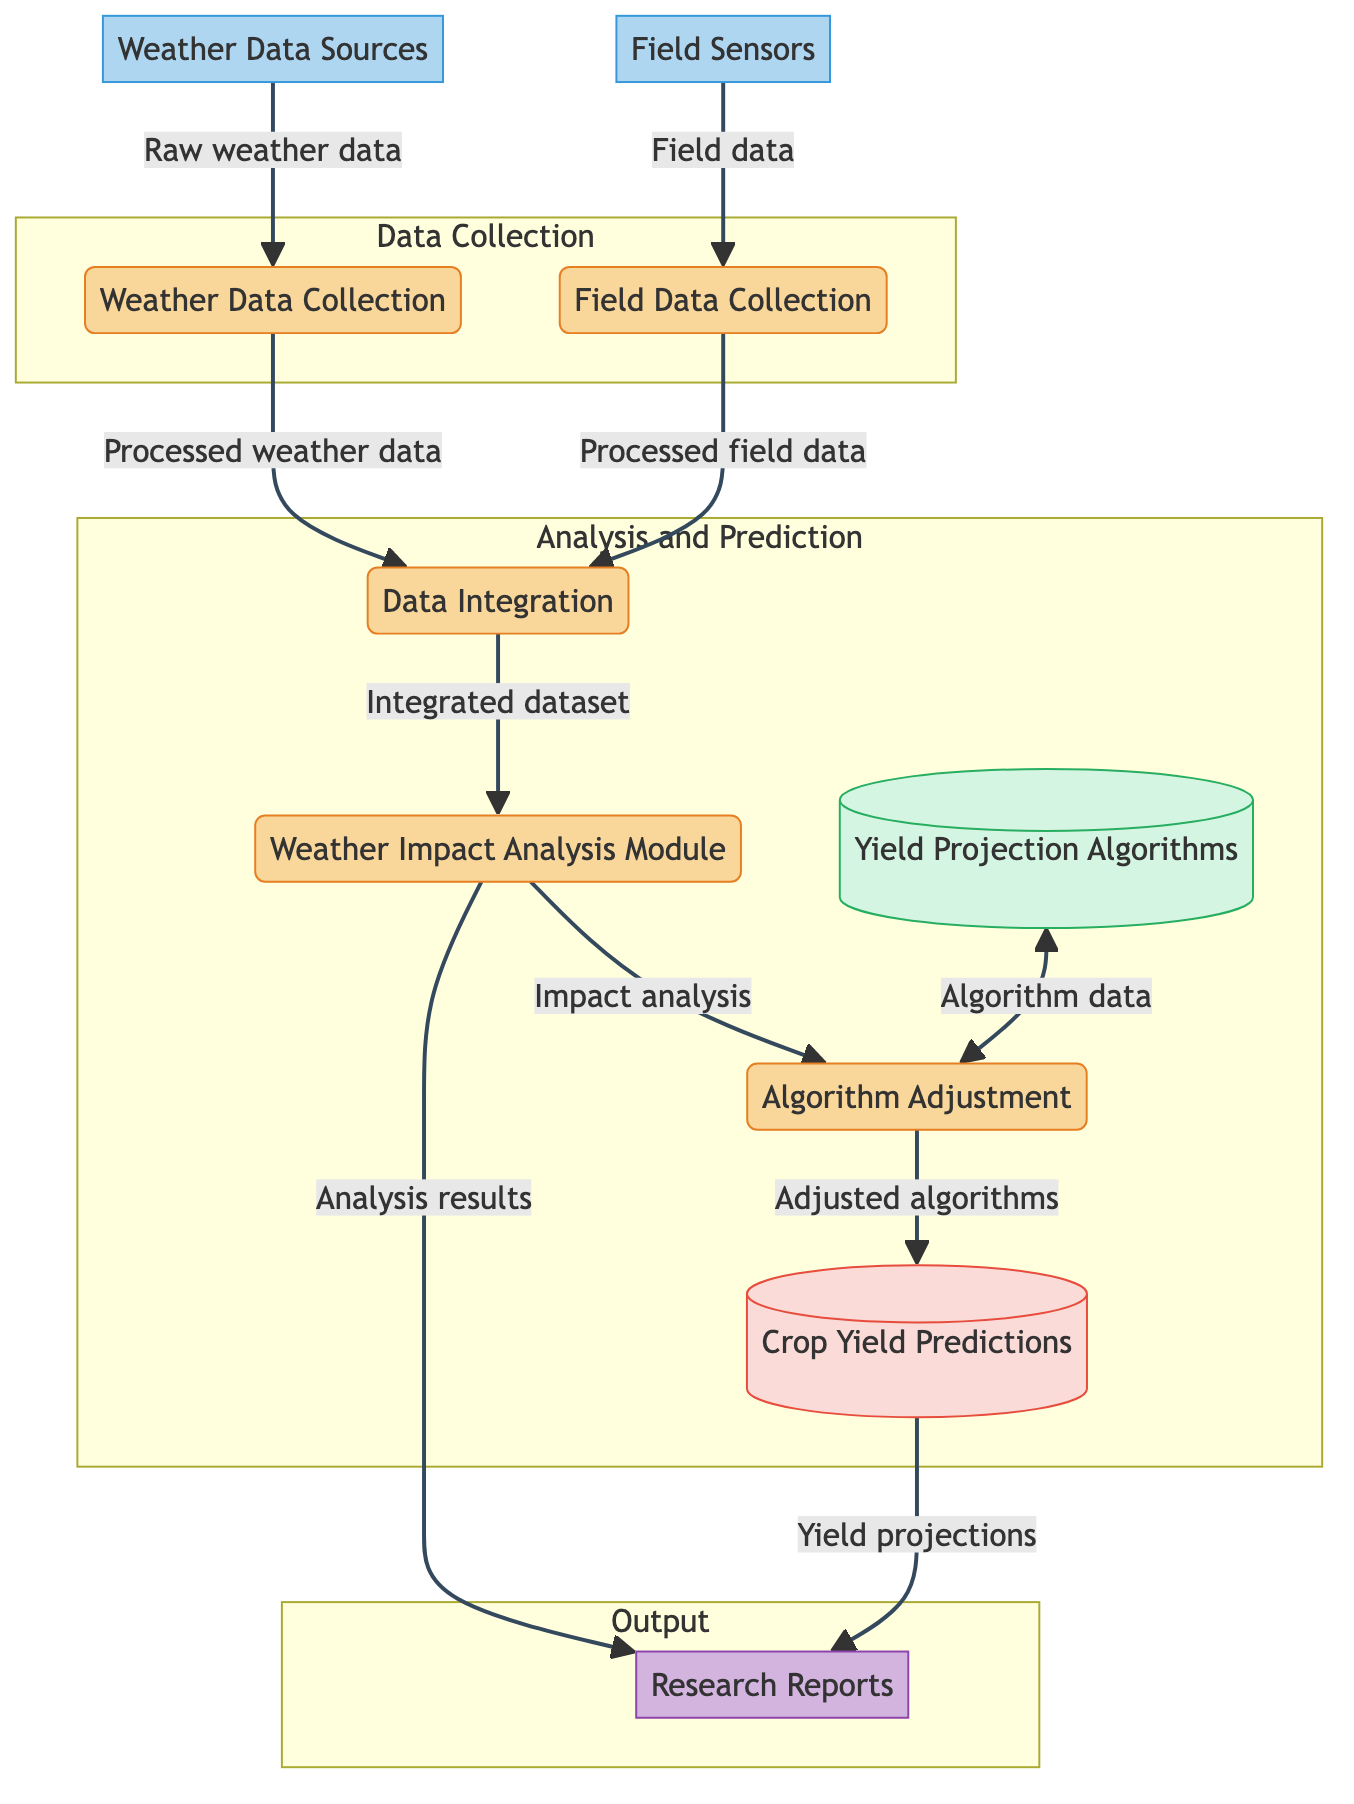What is the first process in the diagram? The diagram starts with the "Weather Data Collection" process, which is visually represented as the first process.
Answer: Weather Data Collection How many external entities are present in the diagram? There are two external entities in the diagram: "Weather Data Sources" and "Field Sensors."
Answer: 2 What is the purpose of the "Data Integration" process? The "Data Integration" process combines processed weather data and processed field data to create a comprehensive dataset.
Answer: Integrate data Which process directly feeds into the "Weather Impact Analysis Module"? The "Data Integration" process directly feeds into the "Weather Impact Analysis Module" with the integrated dataset.
Answer: Data Integration What is the relationship between the "Weather Impact Analysis Module" and "Algorithm Adjustment"? The "Weather Impact Analysis Module" provides impact analysis results that are then used to adjust the algorithms in the "Algorithm Adjustment" process.
Answer: Provides input What is stored in the "Crop Yield Predictions"? The "Crop Yield Predictions" serves as a storage for the yield projections generated by the adjusted algorithms in the "Algorithm Adjustment" process.
Answer: Yield projections Which process outputs research reports? The "Weather Impact Analysis Module" outputs the analysis results into the "Research Reports."
Answer: Weather Impact Analysis Module How many processes are involved in the "Analysis and Prediction" section? The "Analysis and Prediction" section includes five processes: "Data Integration," "Weather Impact Analysis Module," "Algorithm Adjustment," "Yield Projection Algorithms," and "Crop Yield Predictions."
Answer: 5 What type of diagram is represented here? The diagram is a Data Flow Diagram, showing the flow of data through processes and entities related to weather impact assessment on crop yield.
Answer: Data Flow Diagram 